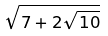Convert formula to latex. <formula><loc_0><loc_0><loc_500><loc_500>\sqrt { 7 + 2 \sqrt { 1 0 } }</formula> 